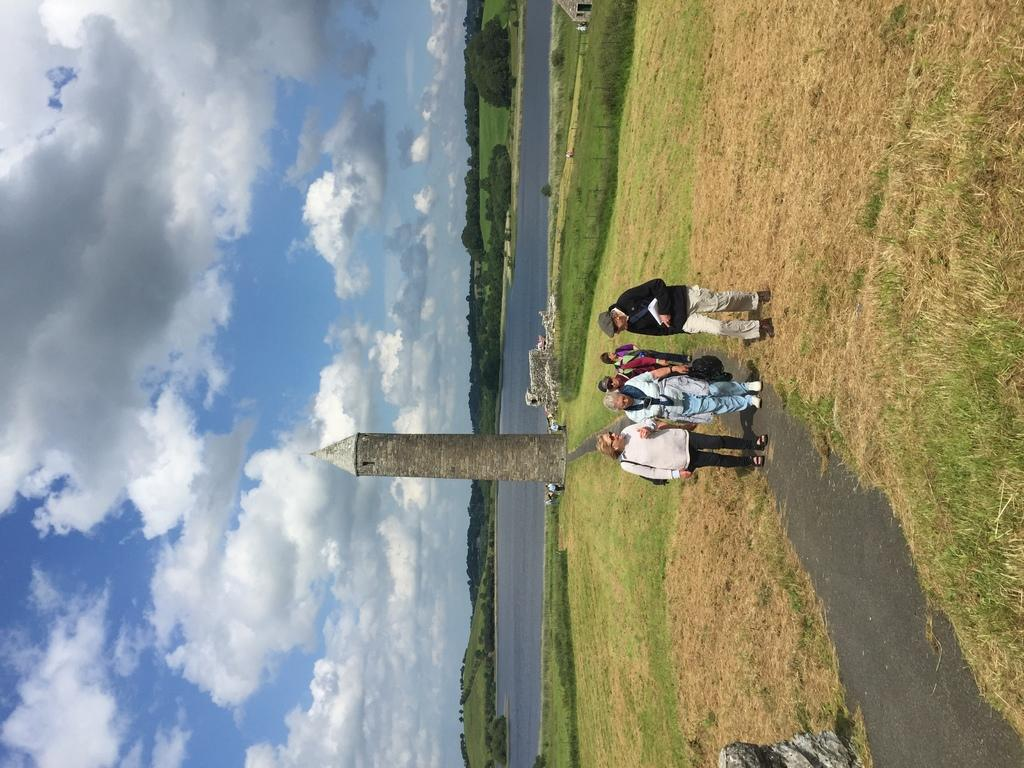How many people are in the image? There is a group of people in the image, but the exact number is not specified. What is the surface the people are standing on? The people are standing on the ground. What type of vegetation can be seen in the image? Grass is present in the image, and there are also trees. What can be seen in the background of the image? The sky is visible in the background of the image, and there are clouds present. What structure is visible in the image? There is a tower in the image. What is the condition of the water in the image? The fact does not specify the condition of the water, only that it is visible. What type of stew is being served in the image? There is no mention of stew in the image; it features a group of people, grass, water, a tower, trees, and a sky with clouds. How many body parts can be seen on each person in the image? The fact does not specify the number of body parts visible on each person, only that there is a group of people in the image. 